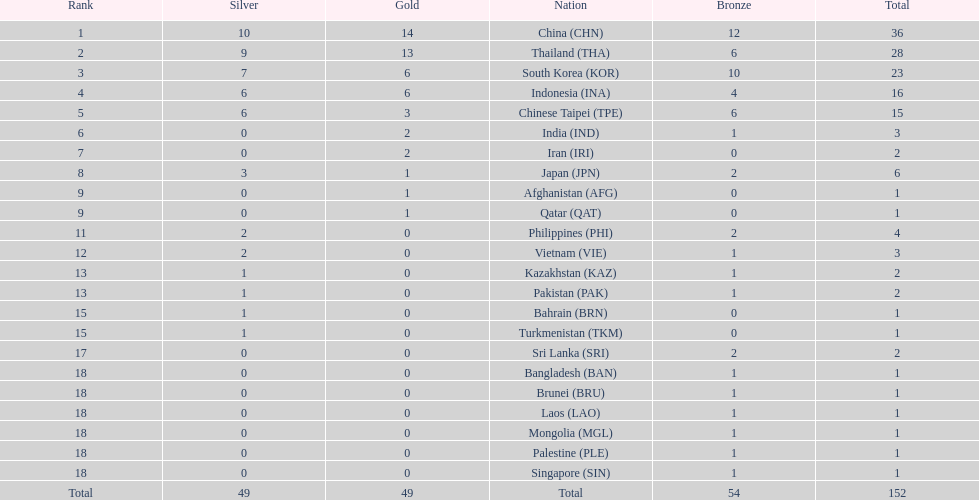How many nations won no silver medals at all? 11. 